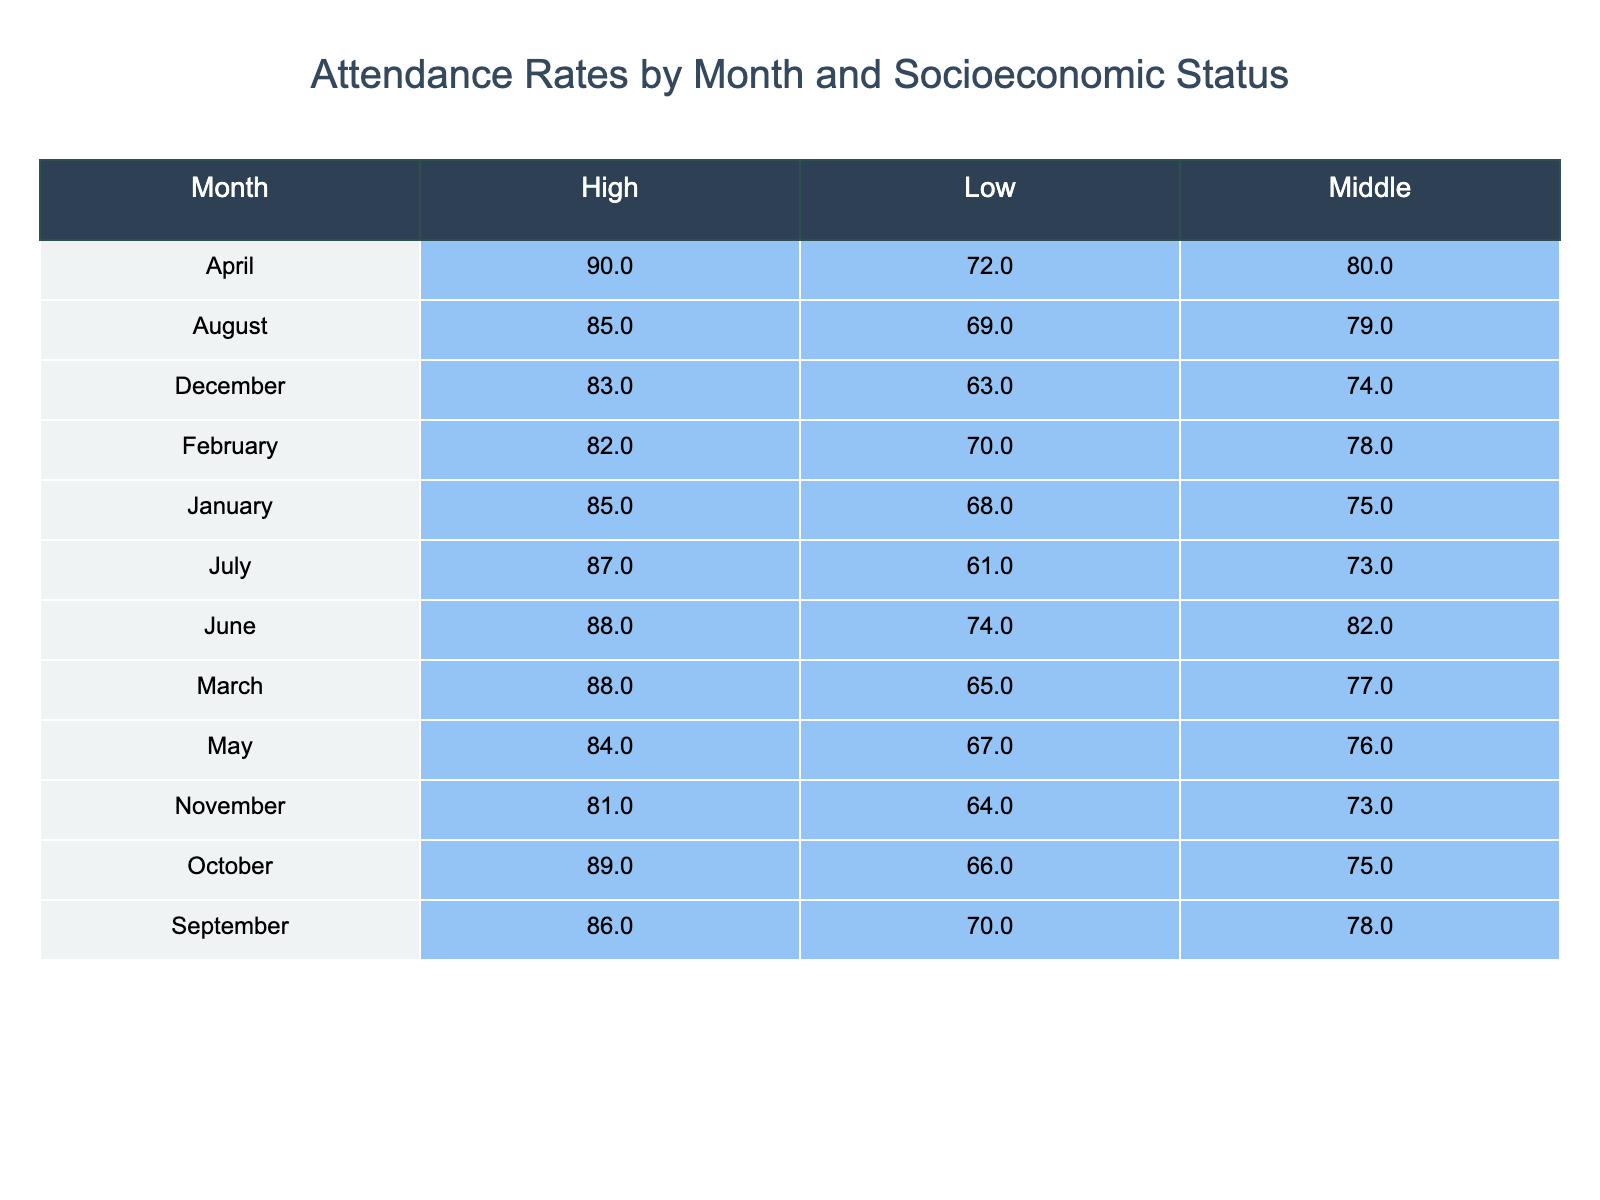What is the attendance rate for the High socioeconomic status in April? Referring to the table, the attendance rate for High socioeconomic status in April is directly stated as 90.
Answer: 90 Which month has the lowest attendance rate for the Low socioeconomic status? By examining the table, July shows an attendance rate of 61, which is lower than all other months listed for Low socioeconomic status.
Answer: July What is the average attendance rate for the Middle socioeconomic status across all months? To find the average for Middle socioeconomic status, we sum the attendance rates for each month: (75 + 78 + 77 + 80 + 76 + 82 + 73 + 79 + 78 + 75 + 73 + 74) = 873. There are 12 months, so the average is 873 / 12 = 72.75.
Answer: 72.75 Is the attendance rate for Low socioeconomic status higher in January than it is in November? In January, the rate is 68, while the rate in November is 64. Therefore, January's rate is higher.
Answer: Yes What is the difference in attendance rates between the High status in January and the Low status in July? In January, the attendance rate for High status is 85, and for Low status in July, it is 61. The difference is 85 - 61 = 24.
Answer: 24 What is the highest attendance rate recorded in the table? Looking through all values in the table, the highest attendance rate is 90, which corresponds to the High socioeconomic status in April.
Answer: 90 In which month is the attendance rate for the Middle socioeconomic status the lowest? The lowest attendance rate for Middle socioeconomic status can be determined by comparing the rates. The lowest value is noted in November at 73.
Answer: November Does the attendance rate for the Low socioeconomic status in March exceed 70? The rate for Low socioeconomic status in March is noted as 65, which does not exceed 70.
Answer: No Which socioeconomic group recorded the highest average attendance rate overall? To determine this, we calculate the average attendance rates for each socioeconomic group. For High: (85 + 82 + 88 + 90 + 84 + 88 + 87 + 85 + 86 + 89 + 81 + 83) = 1,063 / 12 = 88.58. For Middle: (75 + 78 + 77 + 80 + 76 + 82 + 73 + 79 + 78 + 75 + 73 + 74) = 873 / 12 = 72.75. For Low: (68 + 70 + 65 + 72 + 67 + 74 + 61 + 69 + 70 + 66 + 64 + 63) = 853 / 12 = 71.08. The High socioeconomic status has the highest average attendance.
Answer: High 